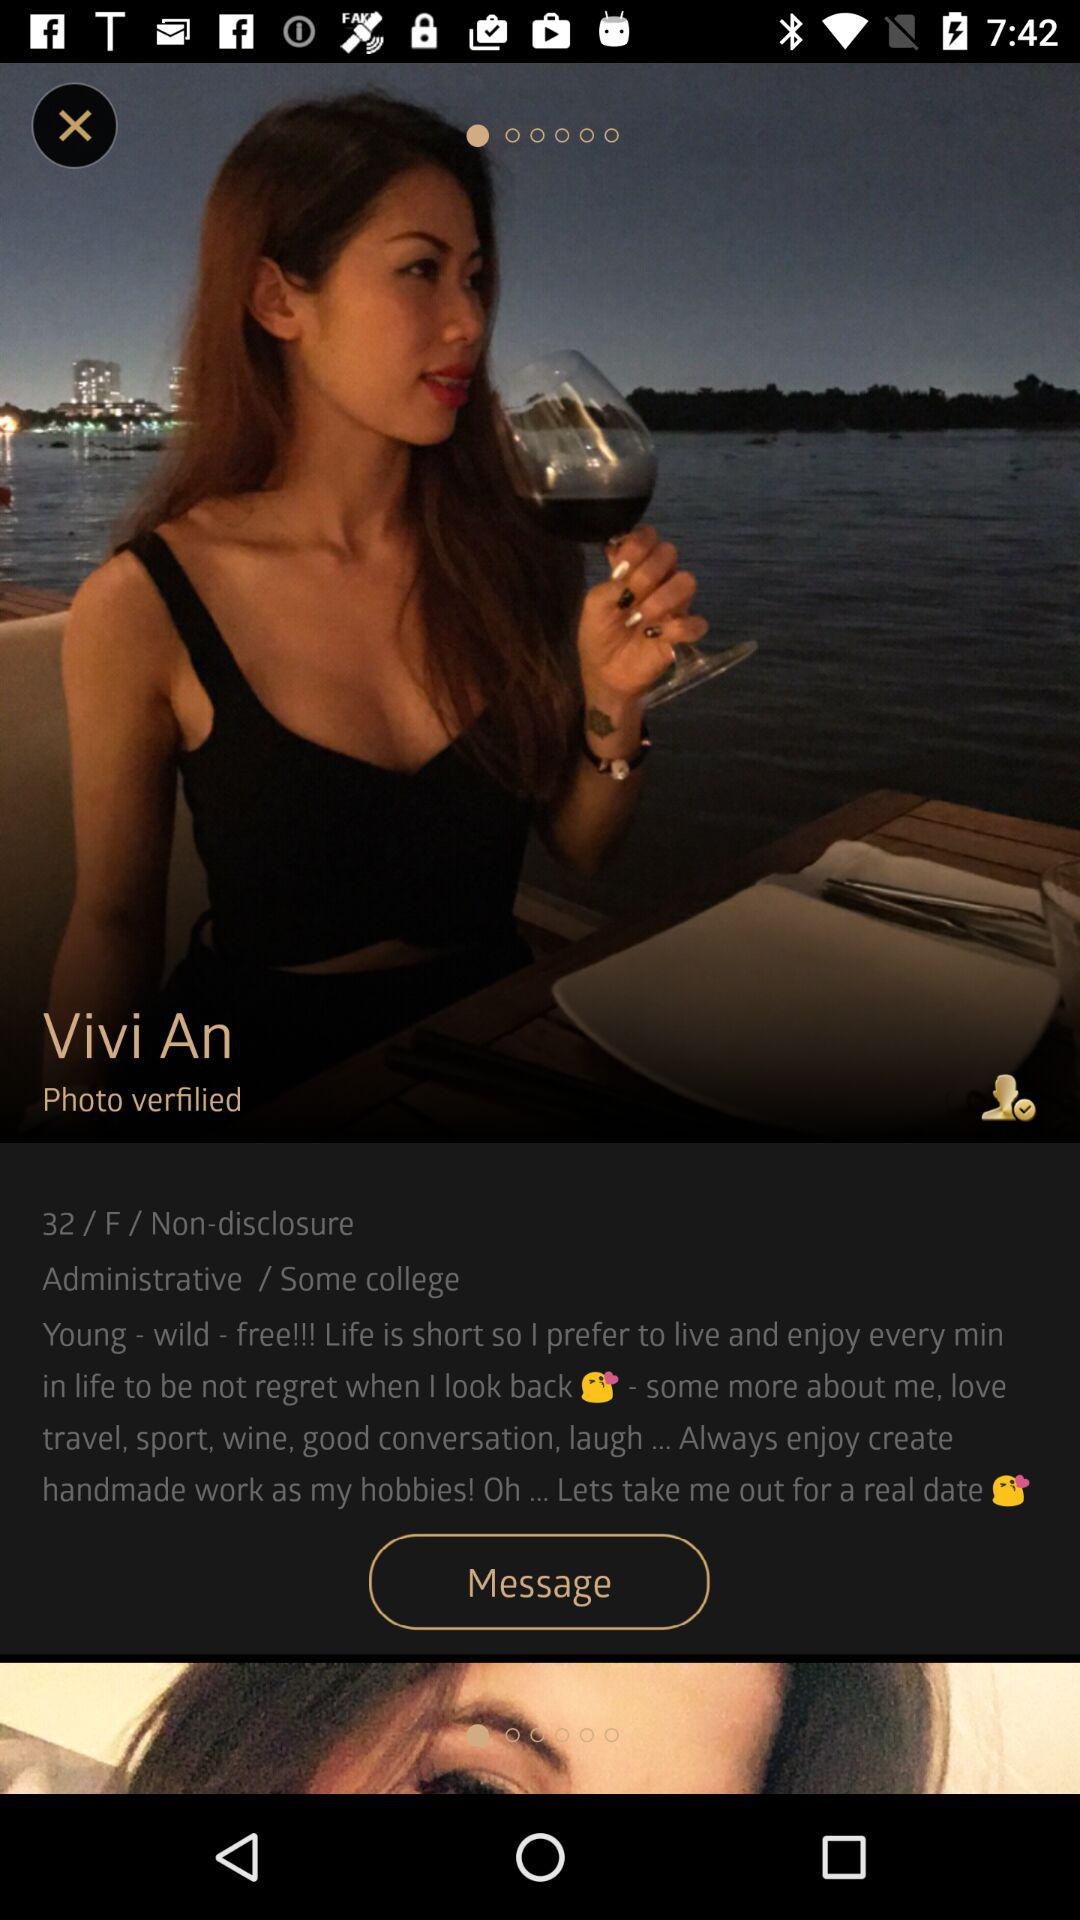What's the age of Vivi An? Vivi An is 32 years old. 